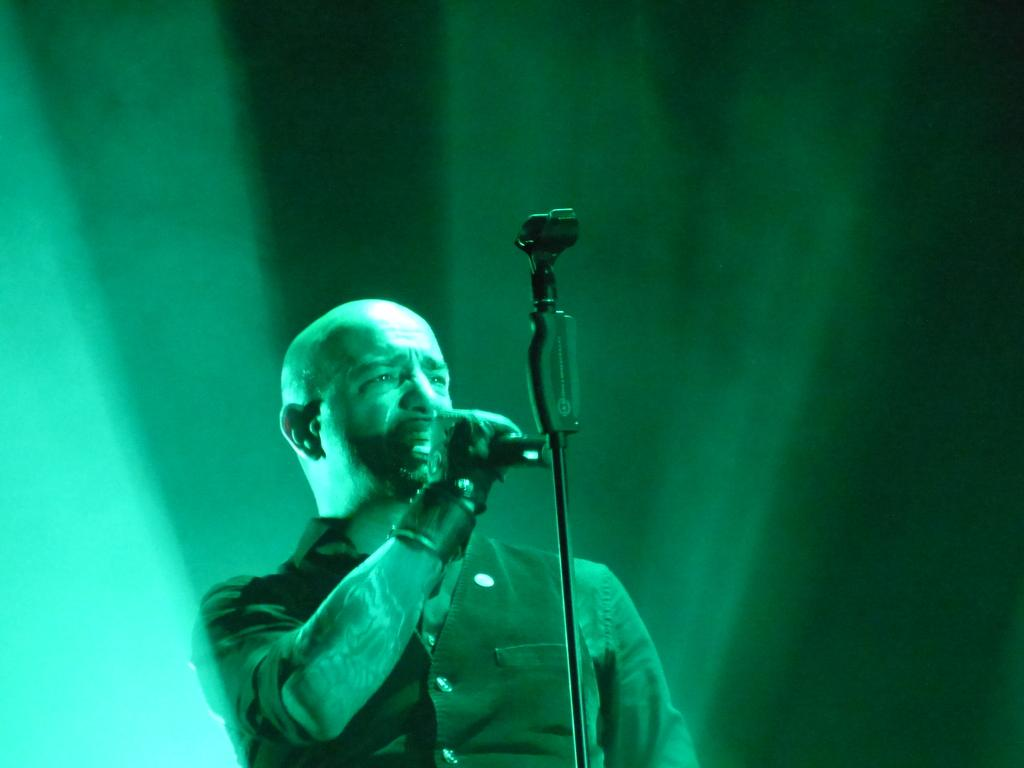What is happening in the image? There is a person in the image who is singing a song. What object is the person holding while singing? The person is holding a microphone in their hand. How many ants can be seen crawling on the person's wound in the image? There are no ants or wounds visible in the image; it features a person singing with a microphone. 